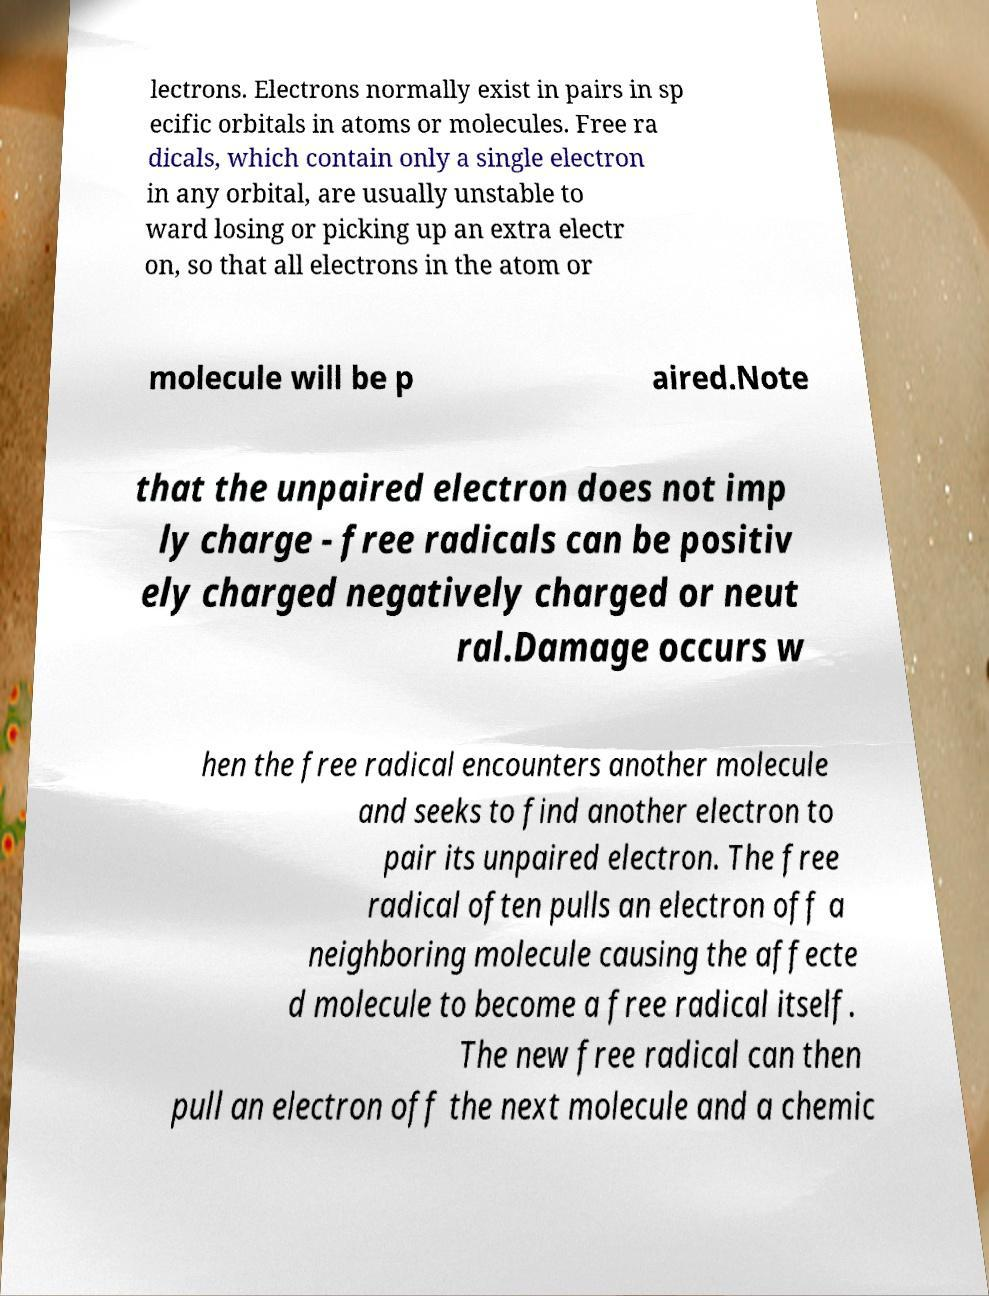Can you accurately transcribe the text from the provided image for me? lectrons. Electrons normally exist in pairs in sp ecific orbitals in atoms or molecules. Free ra dicals, which contain only a single electron in any orbital, are usually unstable to ward losing or picking up an extra electr on, so that all electrons in the atom or molecule will be p aired.Note that the unpaired electron does not imp ly charge - free radicals can be positiv ely charged negatively charged or neut ral.Damage occurs w hen the free radical encounters another molecule and seeks to find another electron to pair its unpaired electron. The free radical often pulls an electron off a neighboring molecule causing the affecte d molecule to become a free radical itself. The new free radical can then pull an electron off the next molecule and a chemic 